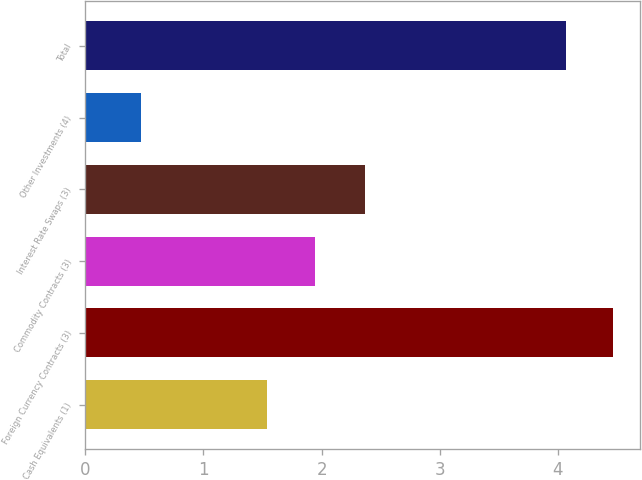<chart> <loc_0><loc_0><loc_500><loc_500><bar_chart><fcel>Cash Equivalents (1)<fcel>Foreign Currency Contracts (3)<fcel>Commodity Contracts (3)<fcel>Interest Rate Swaps (3)<fcel>Other Investments (4)<fcel>Total<nl><fcel>1.54<fcel>4.47<fcel>1.94<fcel>2.37<fcel>0.47<fcel>4.07<nl></chart> 